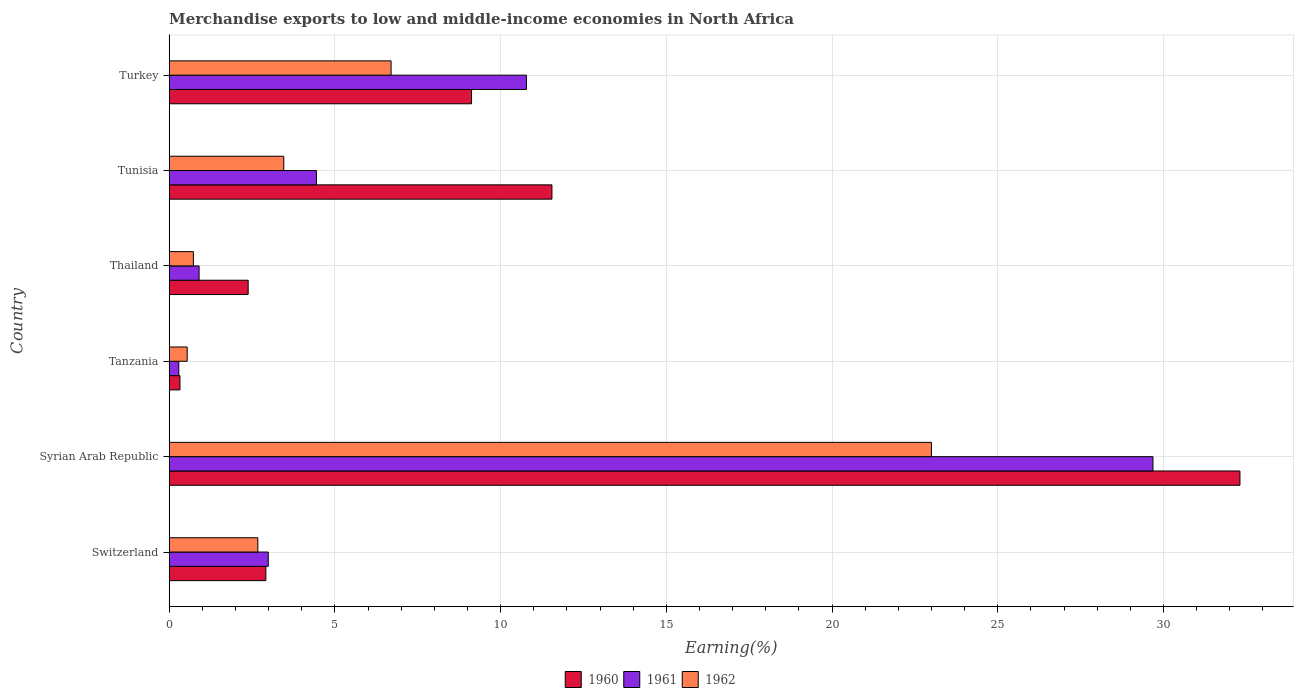How many groups of bars are there?
Provide a short and direct response. 6. Are the number of bars per tick equal to the number of legend labels?
Offer a terse response. Yes. How many bars are there on the 3rd tick from the top?
Keep it short and to the point. 3. How many bars are there on the 2nd tick from the bottom?
Make the answer very short. 3. What is the label of the 1st group of bars from the top?
Provide a succinct answer. Turkey. What is the percentage of amount earned from merchandise exports in 1961 in Syrian Arab Republic?
Keep it short and to the point. 29.68. Across all countries, what is the maximum percentage of amount earned from merchandise exports in 1960?
Offer a terse response. 32.31. Across all countries, what is the minimum percentage of amount earned from merchandise exports in 1960?
Your answer should be compact. 0.32. In which country was the percentage of amount earned from merchandise exports in 1961 maximum?
Keep it short and to the point. Syrian Arab Republic. In which country was the percentage of amount earned from merchandise exports in 1960 minimum?
Offer a terse response. Tanzania. What is the total percentage of amount earned from merchandise exports in 1961 in the graph?
Provide a succinct answer. 49.08. What is the difference between the percentage of amount earned from merchandise exports in 1962 in Switzerland and that in Tanzania?
Offer a terse response. 2.13. What is the difference between the percentage of amount earned from merchandise exports in 1960 in Turkey and the percentage of amount earned from merchandise exports in 1961 in Switzerland?
Your answer should be compact. 6.13. What is the average percentage of amount earned from merchandise exports in 1962 per country?
Give a very brief answer. 6.18. What is the difference between the percentage of amount earned from merchandise exports in 1960 and percentage of amount earned from merchandise exports in 1962 in Turkey?
Make the answer very short. 2.43. What is the ratio of the percentage of amount earned from merchandise exports in 1962 in Tunisia to that in Turkey?
Ensure brevity in your answer.  0.52. What is the difference between the highest and the second highest percentage of amount earned from merchandise exports in 1960?
Offer a very short reply. 20.76. What is the difference between the highest and the lowest percentage of amount earned from merchandise exports in 1961?
Your answer should be very brief. 29.39. In how many countries, is the percentage of amount earned from merchandise exports in 1962 greater than the average percentage of amount earned from merchandise exports in 1962 taken over all countries?
Keep it short and to the point. 2. Is the sum of the percentage of amount earned from merchandise exports in 1962 in Switzerland and Tunisia greater than the maximum percentage of amount earned from merchandise exports in 1961 across all countries?
Ensure brevity in your answer.  No. What does the 3rd bar from the top in Syrian Arab Republic represents?
Your answer should be very brief. 1960. What does the 3rd bar from the bottom in Tunisia represents?
Your response must be concise. 1962. Is it the case that in every country, the sum of the percentage of amount earned from merchandise exports in 1960 and percentage of amount earned from merchandise exports in 1962 is greater than the percentage of amount earned from merchandise exports in 1961?
Provide a succinct answer. Yes. How many bars are there?
Ensure brevity in your answer.  18. Are all the bars in the graph horizontal?
Offer a terse response. Yes. Are the values on the major ticks of X-axis written in scientific E-notation?
Your answer should be compact. No. What is the title of the graph?
Your answer should be compact. Merchandise exports to low and middle-income economies in North Africa. What is the label or title of the X-axis?
Your answer should be compact. Earning(%). What is the label or title of the Y-axis?
Provide a succinct answer. Country. What is the Earning(%) in 1960 in Switzerland?
Your response must be concise. 2.92. What is the Earning(%) in 1961 in Switzerland?
Offer a very short reply. 2.99. What is the Earning(%) in 1962 in Switzerland?
Provide a succinct answer. 2.67. What is the Earning(%) of 1960 in Syrian Arab Republic?
Your response must be concise. 32.31. What is the Earning(%) of 1961 in Syrian Arab Republic?
Give a very brief answer. 29.68. What is the Earning(%) in 1962 in Syrian Arab Republic?
Make the answer very short. 23. What is the Earning(%) of 1960 in Tanzania?
Keep it short and to the point. 0.32. What is the Earning(%) of 1961 in Tanzania?
Your response must be concise. 0.29. What is the Earning(%) of 1962 in Tanzania?
Your response must be concise. 0.54. What is the Earning(%) in 1960 in Thailand?
Your answer should be compact. 2.38. What is the Earning(%) in 1961 in Thailand?
Give a very brief answer. 0.9. What is the Earning(%) of 1962 in Thailand?
Your answer should be compact. 0.73. What is the Earning(%) of 1960 in Tunisia?
Make the answer very short. 11.55. What is the Earning(%) of 1961 in Tunisia?
Provide a succinct answer. 4.44. What is the Earning(%) in 1962 in Tunisia?
Keep it short and to the point. 3.46. What is the Earning(%) in 1960 in Turkey?
Offer a very short reply. 9.12. What is the Earning(%) in 1961 in Turkey?
Your answer should be very brief. 10.78. What is the Earning(%) of 1962 in Turkey?
Provide a succinct answer. 6.69. Across all countries, what is the maximum Earning(%) in 1960?
Your answer should be compact. 32.31. Across all countries, what is the maximum Earning(%) of 1961?
Give a very brief answer. 29.68. Across all countries, what is the maximum Earning(%) in 1962?
Make the answer very short. 23. Across all countries, what is the minimum Earning(%) of 1960?
Your answer should be compact. 0.32. Across all countries, what is the minimum Earning(%) of 1961?
Offer a terse response. 0.29. Across all countries, what is the minimum Earning(%) of 1962?
Your answer should be very brief. 0.54. What is the total Earning(%) of 1960 in the graph?
Make the answer very short. 58.6. What is the total Earning(%) of 1961 in the graph?
Your answer should be compact. 49.08. What is the total Earning(%) of 1962 in the graph?
Keep it short and to the point. 37.1. What is the difference between the Earning(%) in 1960 in Switzerland and that in Syrian Arab Republic?
Keep it short and to the point. -29.39. What is the difference between the Earning(%) of 1961 in Switzerland and that in Syrian Arab Republic?
Ensure brevity in your answer.  -26.69. What is the difference between the Earning(%) of 1962 in Switzerland and that in Syrian Arab Republic?
Offer a very short reply. -20.32. What is the difference between the Earning(%) in 1960 in Switzerland and that in Tanzania?
Offer a terse response. 2.59. What is the difference between the Earning(%) in 1961 in Switzerland and that in Tanzania?
Provide a succinct answer. 2.7. What is the difference between the Earning(%) in 1962 in Switzerland and that in Tanzania?
Give a very brief answer. 2.13. What is the difference between the Earning(%) in 1960 in Switzerland and that in Thailand?
Make the answer very short. 0.53. What is the difference between the Earning(%) of 1961 in Switzerland and that in Thailand?
Provide a short and direct response. 2.09. What is the difference between the Earning(%) of 1962 in Switzerland and that in Thailand?
Keep it short and to the point. 1.94. What is the difference between the Earning(%) of 1960 in Switzerland and that in Tunisia?
Your answer should be very brief. -8.63. What is the difference between the Earning(%) of 1961 in Switzerland and that in Tunisia?
Offer a very short reply. -1.45. What is the difference between the Earning(%) of 1962 in Switzerland and that in Tunisia?
Give a very brief answer. -0.78. What is the difference between the Earning(%) of 1960 in Switzerland and that in Turkey?
Your answer should be compact. -6.21. What is the difference between the Earning(%) of 1961 in Switzerland and that in Turkey?
Keep it short and to the point. -7.79. What is the difference between the Earning(%) in 1962 in Switzerland and that in Turkey?
Offer a very short reply. -4.02. What is the difference between the Earning(%) in 1960 in Syrian Arab Republic and that in Tanzania?
Offer a very short reply. 31.98. What is the difference between the Earning(%) in 1961 in Syrian Arab Republic and that in Tanzania?
Make the answer very short. 29.39. What is the difference between the Earning(%) in 1962 in Syrian Arab Republic and that in Tanzania?
Your response must be concise. 22.46. What is the difference between the Earning(%) of 1960 in Syrian Arab Republic and that in Thailand?
Make the answer very short. 29.93. What is the difference between the Earning(%) in 1961 in Syrian Arab Republic and that in Thailand?
Provide a succinct answer. 28.78. What is the difference between the Earning(%) of 1962 in Syrian Arab Republic and that in Thailand?
Give a very brief answer. 22.27. What is the difference between the Earning(%) in 1960 in Syrian Arab Republic and that in Tunisia?
Ensure brevity in your answer.  20.76. What is the difference between the Earning(%) of 1961 in Syrian Arab Republic and that in Tunisia?
Provide a short and direct response. 25.24. What is the difference between the Earning(%) of 1962 in Syrian Arab Republic and that in Tunisia?
Offer a terse response. 19.54. What is the difference between the Earning(%) of 1960 in Syrian Arab Republic and that in Turkey?
Your response must be concise. 23.19. What is the difference between the Earning(%) in 1961 in Syrian Arab Republic and that in Turkey?
Give a very brief answer. 18.91. What is the difference between the Earning(%) of 1962 in Syrian Arab Republic and that in Turkey?
Give a very brief answer. 16.3. What is the difference between the Earning(%) in 1960 in Tanzania and that in Thailand?
Your answer should be compact. -2.06. What is the difference between the Earning(%) in 1961 in Tanzania and that in Thailand?
Provide a succinct answer. -0.61. What is the difference between the Earning(%) in 1962 in Tanzania and that in Thailand?
Provide a succinct answer. -0.19. What is the difference between the Earning(%) of 1960 in Tanzania and that in Tunisia?
Offer a terse response. -11.22. What is the difference between the Earning(%) in 1961 in Tanzania and that in Tunisia?
Offer a very short reply. -4.15. What is the difference between the Earning(%) in 1962 in Tanzania and that in Tunisia?
Offer a terse response. -2.91. What is the difference between the Earning(%) in 1960 in Tanzania and that in Turkey?
Offer a terse response. -8.8. What is the difference between the Earning(%) in 1961 in Tanzania and that in Turkey?
Offer a terse response. -10.49. What is the difference between the Earning(%) of 1962 in Tanzania and that in Turkey?
Provide a short and direct response. -6.15. What is the difference between the Earning(%) of 1960 in Thailand and that in Tunisia?
Offer a very short reply. -9.17. What is the difference between the Earning(%) in 1961 in Thailand and that in Tunisia?
Ensure brevity in your answer.  -3.54. What is the difference between the Earning(%) in 1962 in Thailand and that in Tunisia?
Your answer should be very brief. -2.73. What is the difference between the Earning(%) of 1960 in Thailand and that in Turkey?
Offer a terse response. -6.74. What is the difference between the Earning(%) of 1961 in Thailand and that in Turkey?
Make the answer very short. -9.88. What is the difference between the Earning(%) in 1962 in Thailand and that in Turkey?
Your answer should be compact. -5.97. What is the difference between the Earning(%) in 1960 in Tunisia and that in Turkey?
Give a very brief answer. 2.43. What is the difference between the Earning(%) in 1961 in Tunisia and that in Turkey?
Make the answer very short. -6.34. What is the difference between the Earning(%) in 1962 in Tunisia and that in Turkey?
Provide a short and direct response. -3.24. What is the difference between the Earning(%) of 1960 in Switzerland and the Earning(%) of 1961 in Syrian Arab Republic?
Offer a very short reply. -26.77. What is the difference between the Earning(%) of 1960 in Switzerland and the Earning(%) of 1962 in Syrian Arab Republic?
Your answer should be compact. -20.08. What is the difference between the Earning(%) in 1961 in Switzerland and the Earning(%) in 1962 in Syrian Arab Republic?
Keep it short and to the point. -20.01. What is the difference between the Earning(%) of 1960 in Switzerland and the Earning(%) of 1961 in Tanzania?
Your answer should be compact. 2.63. What is the difference between the Earning(%) of 1960 in Switzerland and the Earning(%) of 1962 in Tanzania?
Make the answer very short. 2.37. What is the difference between the Earning(%) in 1961 in Switzerland and the Earning(%) in 1962 in Tanzania?
Ensure brevity in your answer.  2.45. What is the difference between the Earning(%) in 1960 in Switzerland and the Earning(%) in 1961 in Thailand?
Offer a terse response. 2.02. What is the difference between the Earning(%) in 1960 in Switzerland and the Earning(%) in 1962 in Thailand?
Offer a terse response. 2.19. What is the difference between the Earning(%) in 1961 in Switzerland and the Earning(%) in 1962 in Thailand?
Give a very brief answer. 2.26. What is the difference between the Earning(%) in 1960 in Switzerland and the Earning(%) in 1961 in Tunisia?
Make the answer very short. -1.53. What is the difference between the Earning(%) in 1960 in Switzerland and the Earning(%) in 1962 in Tunisia?
Provide a short and direct response. -0.54. What is the difference between the Earning(%) of 1961 in Switzerland and the Earning(%) of 1962 in Tunisia?
Your answer should be compact. -0.47. What is the difference between the Earning(%) of 1960 in Switzerland and the Earning(%) of 1961 in Turkey?
Your response must be concise. -7.86. What is the difference between the Earning(%) of 1960 in Switzerland and the Earning(%) of 1962 in Turkey?
Your answer should be compact. -3.78. What is the difference between the Earning(%) in 1961 in Switzerland and the Earning(%) in 1962 in Turkey?
Provide a short and direct response. -3.71. What is the difference between the Earning(%) of 1960 in Syrian Arab Republic and the Earning(%) of 1961 in Tanzania?
Ensure brevity in your answer.  32.02. What is the difference between the Earning(%) in 1960 in Syrian Arab Republic and the Earning(%) in 1962 in Tanzania?
Your answer should be very brief. 31.77. What is the difference between the Earning(%) in 1961 in Syrian Arab Republic and the Earning(%) in 1962 in Tanzania?
Your answer should be compact. 29.14. What is the difference between the Earning(%) in 1960 in Syrian Arab Republic and the Earning(%) in 1961 in Thailand?
Provide a short and direct response. 31.41. What is the difference between the Earning(%) in 1960 in Syrian Arab Republic and the Earning(%) in 1962 in Thailand?
Keep it short and to the point. 31.58. What is the difference between the Earning(%) of 1961 in Syrian Arab Republic and the Earning(%) of 1962 in Thailand?
Make the answer very short. 28.95. What is the difference between the Earning(%) of 1960 in Syrian Arab Republic and the Earning(%) of 1961 in Tunisia?
Keep it short and to the point. 27.87. What is the difference between the Earning(%) in 1960 in Syrian Arab Republic and the Earning(%) in 1962 in Tunisia?
Your response must be concise. 28.85. What is the difference between the Earning(%) of 1961 in Syrian Arab Republic and the Earning(%) of 1962 in Tunisia?
Ensure brevity in your answer.  26.23. What is the difference between the Earning(%) in 1960 in Syrian Arab Republic and the Earning(%) in 1961 in Turkey?
Give a very brief answer. 21.53. What is the difference between the Earning(%) of 1960 in Syrian Arab Republic and the Earning(%) of 1962 in Turkey?
Your answer should be compact. 25.61. What is the difference between the Earning(%) in 1961 in Syrian Arab Republic and the Earning(%) in 1962 in Turkey?
Your answer should be very brief. 22.99. What is the difference between the Earning(%) in 1960 in Tanzania and the Earning(%) in 1961 in Thailand?
Offer a terse response. -0.58. What is the difference between the Earning(%) of 1960 in Tanzania and the Earning(%) of 1962 in Thailand?
Your response must be concise. -0.41. What is the difference between the Earning(%) in 1961 in Tanzania and the Earning(%) in 1962 in Thailand?
Your answer should be compact. -0.44. What is the difference between the Earning(%) of 1960 in Tanzania and the Earning(%) of 1961 in Tunisia?
Ensure brevity in your answer.  -4.12. What is the difference between the Earning(%) of 1960 in Tanzania and the Earning(%) of 1962 in Tunisia?
Your response must be concise. -3.13. What is the difference between the Earning(%) of 1961 in Tanzania and the Earning(%) of 1962 in Tunisia?
Provide a short and direct response. -3.17. What is the difference between the Earning(%) in 1960 in Tanzania and the Earning(%) in 1961 in Turkey?
Your answer should be compact. -10.45. What is the difference between the Earning(%) of 1960 in Tanzania and the Earning(%) of 1962 in Turkey?
Your answer should be compact. -6.37. What is the difference between the Earning(%) in 1961 in Tanzania and the Earning(%) in 1962 in Turkey?
Your answer should be very brief. -6.41. What is the difference between the Earning(%) in 1960 in Thailand and the Earning(%) in 1961 in Tunisia?
Make the answer very short. -2.06. What is the difference between the Earning(%) in 1960 in Thailand and the Earning(%) in 1962 in Tunisia?
Offer a very short reply. -1.07. What is the difference between the Earning(%) in 1961 in Thailand and the Earning(%) in 1962 in Tunisia?
Provide a succinct answer. -2.56. What is the difference between the Earning(%) in 1960 in Thailand and the Earning(%) in 1961 in Turkey?
Your response must be concise. -8.4. What is the difference between the Earning(%) of 1960 in Thailand and the Earning(%) of 1962 in Turkey?
Make the answer very short. -4.31. What is the difference between the Earning(%) in 1961 in Thailand and the Earning(%) in 1962 in Turkey?
Keep it short and to the point. -5.79. What is the difference between the Earning(%) in 1960 in Tunisia and the Earning(%) in 1961 in Turkey?
Keep it short and to the point. 0.77. What is the difference between the Earning(%) of 1960 in Tunisia and the Earning(%) of 1962 in Turkey?
Make the answer very short. 4.85. What is the difference between the Earning(%) of 1961 in Tunisia and the Earning(%) of 1962 in Turkey?
Give a very brief answer. -2.25. What is the average Earning(%) in 1960 per country?
Your response must be concise. 9.77. What is the average Earning(%) in 1961 per country?
Keep it short and to the point. 8.18. What is the average Earning(%) of 1962 per country?
Provide a succinct answer. 6.18. What is the difference between the Earning(%) of 1960 and Earning(%) of 1961 in Switzerland?
Ensure brevity in your answer.  -0.07. What is the difference between the Earning(%) in 1960 and Earning(%) in 1962 in Switzerland?
Your answer should be compact. 0.24. What is the difference between the Earning(%) of 1961 and Earning(%) of 1962 in Switzerland?
Keep it short and to the point. 0.31. What is the difference between the Earning(%) of 1960 and Earning(%) of 1961 in Syrian Arab Republic?
Your answer should be compact. 2.62. What is the difference between the Earning(%) of 1960 and Earning(%) of 1962 in Syrian Arab Republic?
Make the answer very short. 9.31. What is the difference between the Earning(%) in 1961 and Earning(%) in 1962 in Syrian Arab Republic?
Your response must be concise. 6.68. What is the difference between the Earning(%) in 1960 and Earning(%) in 1961 in Tanzania?
Offer a very short reply. 0.03. What is the difference between the Earning(%) of 1960 and Earning(%) of 1962 in Tanzania?
Ensure brevity in your answer.  -0.22. What is the difference between the Earning(%) of 1961 and Earning(%) of 1962 in Tanzania?
Give a very brief answer. -0.25. What is the difference between the Earning(%) in 1960 and Earning(%) in 1961 in Thailand?
Provide a short and direct response. 1.48. What is the difference between the Earning(%) in 1960 and Earning(%) in 1962 in Thailand?
Your response must be concise. 1.65. What is the difference between the Earning(%) in 1961 and Earning(%) in 1962 in Thailand?
Ensure brevity in your answer.  0.17. What is the difference between the Earning(%) in 1960 and Earning(%) in 1961 in Tunisia?
Give a very brief answer. 7.11. What is the difference between the Earning(%) in 1960 and Earning(%) in 1962 in Tunisia?
Provide a succinct answer. 8.09. What is the difference between the Earning(%) of 1961 and Earning(%) of 1962 in Tunisia?
Provide a short and direct response. 0.99. What is the difference between the Earning(%) in 1960 and Earning(%) in 1961 in Turkey?
Offer a terse response. -1.66. What is the difference between the Earning(%) of 1960 and Earning(%) of 1962 in Turkey?
Your answer should be very brief. 2.43. What is the difference between the Earning(%) of 1961 and Earning(%) of 1962 in Turkey?
Your answer should be compact. 4.08. What is the ratio of the Earning(%) of 1960 in Switzerland to that in Syrian Arab Republic?
Provide a succinct answer. 0.09. What is the ratio of the Earning(%) in 1961 in Switzerland to that in Syrian Arab Republic?
Give a very brief answer. 0.1. What is the ratio of the Earning(%) in 1962 in Switzerland to that in Syrian Arab Republic?
Give a very brief answer. 0.12. What is the ratio of the Earning(%) of 1960 in Switzerland to that in Tanzania?
Make the answer very short. 9. What is the ratio of the Earning(%) in 1961 in Switzerland to that in Tanzania?
Give a very brief answer. 10.33. What is the ratio of the Earning(%) in 1962 in Switzerland to that in Tanzania?
Make the answer very short. 4.93. What is the ratio of the Earning(%) in 1960 in Switzerland to that in Thailand?
Offer a very short reply. 1.22. What is the ratio of the Earning(%) in 1961 in Switzerland to that in Thailand?
Keep it short and to the point. 3.31. What is the ratio of the Earning(%) in 1962 in Switzerland to that in Thailand?
Keep it short and to the point. 3.67. What is the ratio of the Earning(%) in 1960 in Switzerland to that in Tunisia?
Your response must be concise. 0.25. What is the ratio of the Earning(%) in 1961 in Switzerland to that in Tunisia?
Make the answer very short. 0.67. What is the ratio of the Earning(%) of 1962 in Switzerland to that in Tunisia?
Offer a very short reply. 0.77. What is the ratio of the Earning(%) in 1960 in Switzerland to that in Turkey?
Offer a very short reply. 0.32. What is the ratio of the Earning(%) in 1961 in Switzerland to that in Turkey?
Your answer should be very brief. 0.28. What is the ratio of the Earning(%) of 1962 in Switzerland to that in Turkey?
Offer a very short reply. 0.4. What is the ratio of the Earning(%) of 1960 in Syrian Arab Republic to that in Tanzania?
Provide a succinct answer. 99.64. What is the ratio of the Earning(%) in 1961 in Syrian Arab Republic to that in Tanzania?
Give a very brief answer. 102.56. What is the ratio of the Earning(%) of 1962 in Syrian Arab Republic to that in Tanzania?
Keep it short and to the point. 42.38. What is the ratio of the Earning(%) in 1960 in Syrian Arab Republic to that in Thailand?
Offer a terse response. 13.56. What is the ratio of the Earning(%) of 1961 in Syrian Arab Republic to that in Thailand?
Offer a terse response. 32.92. What is the ratio of the Earning(%) in 1962 in Syrian Arab Republic to that in Thailand?
Give a very brief answer. 31.53. What is the ratio of the Earning(%) of 1960 in Syrian Arab Republic to that in Tunisia?
Provide a short and direct response. 2.8. What is the ratio of the Earning(%) of 1961 in Syrian Arab Republic to that in Tunisia?
Make the answer very short. 6.68. What is the ratio of the Earning(%) of 1962 in Syrian Arab Republic to that in Tunisia?
Make the answer very short. 6.65. What is the ratio of the Earning(%) in 1960 in Syrian Arab Republic to that in Turkey?
Provide a short and direct response. 3.54. What is the ratio of the Earning(%) in 1961 in Syrian Arab Republic to that in Turkey?
Offer a very short reply. 2.75. What is the ratio of the Earning(%) of 1962 in Syrian Arab Republic to that in Turkey?
Your answer should be compact. 3.44. What is the ratio of the Earning(%) of 1960 in Tanzania to that in Thailand?
Keep it short and to the point. 0.14. What is the ratio of the Earning(%) of 1961 in Tanzania to that in Thailand?
Your answer should be very brief. 0.32. What is the ratio of the Earning(%) in 1962 in Tanzania to that in Thailand?
Provide a succinct answer. 0.74. What is the ratio of the Earning(%) of 1960 in Tanzania to that in Tunisia?
Provide a short and direct response. 0.03. What is the ratio of the Earning(%) of 1961 in Tanzania to that in Tunisia?
Your answer should be compact. 0.07. What is the ratio of the Earning(%) of 1962 in Tanzania to that in Tunisia?
Provide a succinct answer. 0.16. What is the ratio of the Earning(%) in 1960 in Tanzania to that in Turkey?
Make the answer very short. 0.04. What is the ratio of the Earning(%) of 1961 in Tanzania to that in Turkey?
Provide a short and direct response. 0.03. What is the ratio of the Earning(%) of 1962 in Tanzania to that in Turkey?
Your answer should be very brief. 0.08. What is the ratio of the Earning(%) of 1960 in Thailand to that in Tunisia?
Give a very brief answer. 0.21. What is the ratio of the Earning(%) of 1961 in Thailand to that in Tunisia?
Your answer should be very brief. 0.2. What is the ratio of the Earning(%) in 1962 in Thailand to that in Tunisia?
Offer a very short reply. 0.21. What is the ratio of the Earning(%) in 1960 in Thailand to that in Turkey?
Offer a terse response. 0.26. What is the ratio of the Earning(%) of 1961 in Thailand to that in Turkey?
Provide a succinct answer. 0.08. What is the ratio of the Earning(%) of 1962 in Thailand to that in Turkey?
Provide a short and direct response. 0.11. What is the ratio of the Earning(%) of 1960 in Tunisia to that in Turkey?
Provide a short and direct response. 1.27. What is the ratio of the Earning(%) in 1961 in Tunisia to that in Turkey?
Keep it short and to the point. 0.41. What is the ratio of the Earning(%) of 1962 in Tunisia to that in Turkey?
Keep it short and to the point. 0.52. What is the difference between the highest and the second highest Earning(%) of 1960?
Your response must be concise. 20.76. What is the difference between the highest and the second highest Earning(%) in 1961?
Give a very brief answer. 18.91. What is the difference between the highest and the second highest Earning(%) in 1962?
Make the answer very short. 16.3. What is the difference between the highest and the lowest Earning(%) in 1960?
Provide a succinct answer. 31.98. What is the difference between the highest and the lowest Earning(%) of 1961?
Provide a short and direct response. 29.39. What is the difference between the highest and the lowest Earning(%) in 1962?
Your answer should be compact. 22.46. 